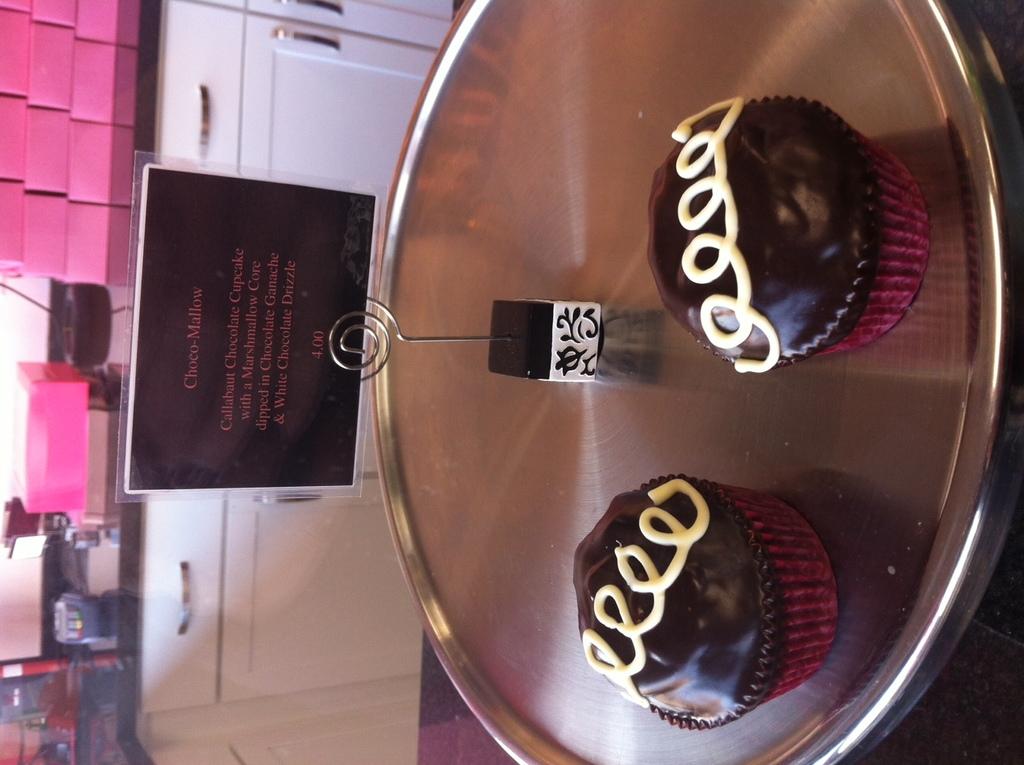What is the name of this food item?
Keep it short and to the point. Choco-mallow. How much does one cost?
Give a very brief answer. 4.00. 